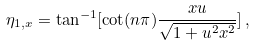Convert formula to latex. <formula><loc_0><loc_0><loc_500><loc_500>\eta _ { 1 , x } = \tan ^ { - 1 } [ \cot ( n \pi ) \frac { x u } { \sqrt { 1 + u ^ { 2 } x ^ { 2 } } } ] \, ,</formula> 